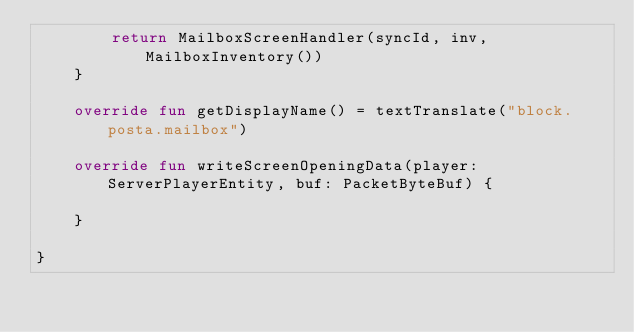Convert code to text. <code><loc_0><loc_0><loc_500><loc_500><_Kotlin_>        return MailboxScreenHandler(syncId, inv, MailboxInventory())
    }

    override fun getDisplayName() = textTranslate("block.posta.mailbox")

    override fun writeScreenOpeningData(player: ServerPlayerEntity, buf: PacketByteBuf) {

    }

}</code> 